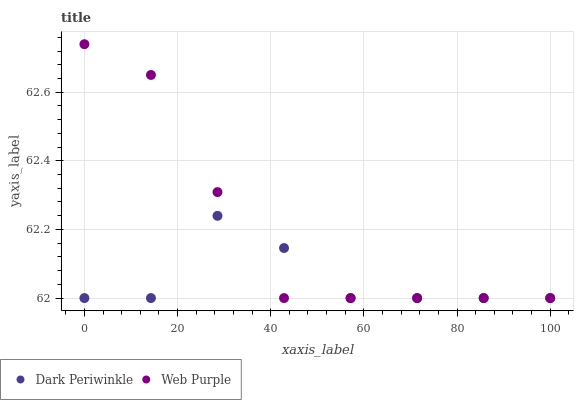Does Dark Periwinkle have the minimum area under the curve?
Answer yes or no. Yes. Does Web Purple have the maximum area under the curve?
Answer yes or no. Yes. Does Dark Periwinkle have the maximum area under the curve?
Answer yes or no. No. Is Web Purple the smoothest?
Answer yes or no. Yes. Is Dark Periwinkle the roughest?
Answer yes or no. Yes. Is Dark Periwinkle the smoothest?
Answer yes or no. No. Does Web Purple have the lowest value?
Answer yes or no. Yes. Does Web Purple have the highest value?
Answer yes or no. Yes. Does Dark Periwinkle have the highest value?
Answer yes or no. No. Does Dark Periwinkle intersect Web Purple?
Answer yes or no. Yes. Is Dark Periwinkle less than Web Purple?
Answer yes or no. No. Is Dark Periwinkle greater than Web Purple?
Answer yes or no. No. 